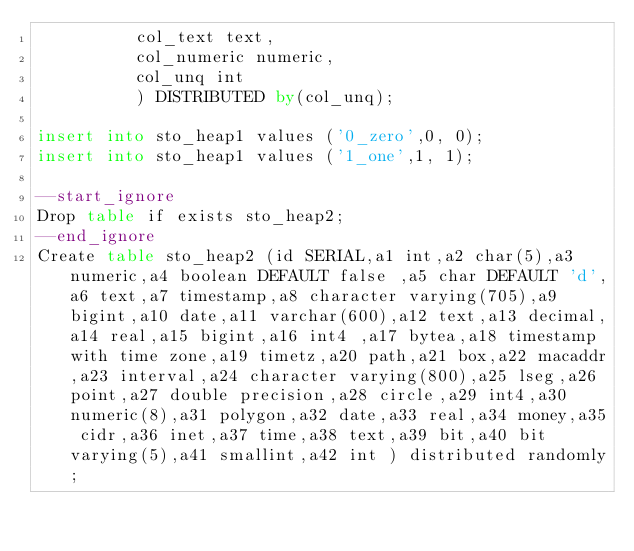<code> <loc_0><loc_0><loc_500><loc_500><_SQL_>          col_text text,
          col_numeric numeric,
          col_unq int
          ) DISTRIBUTED by(col_unq);

insert into sto_heap1 values ('0_zero',0, 0);
insert into sto_heap1 values ('1_one',1, 1);

--start_ignore
Drop table if exists sto_heap2;
--end_ignore
Create table sto_heap2 (id SERIAL,a1 int,a2 char(5),a3 numeric,a4 boolean DEFAULT false ,a5 char DEFAULT 'd',a6 text,a7 timestamp,a8 character varying(705),a9 bigint,a10 date,a11 varchar(600),a12 text,a13 decimal,a14 real,a15 bigint,a16 int4 ,a17 bytea,a18 timestamp with time zone,a19 timetz,a20 path,a21 box,a22 macaddr,a23 interval,a24 character varying(800),a25 lseg,a26 point,a27 double precision,a28 circle,a29 int4,a30 numeric(8),a31 polygon,a32 date,a33 real,a34 money,a35 cidr,a36 inet,a37 time,a38 text,a39 bit,a40 bit varying(5),a41 smallint,a42 int ) distributed randomly;
</code> 